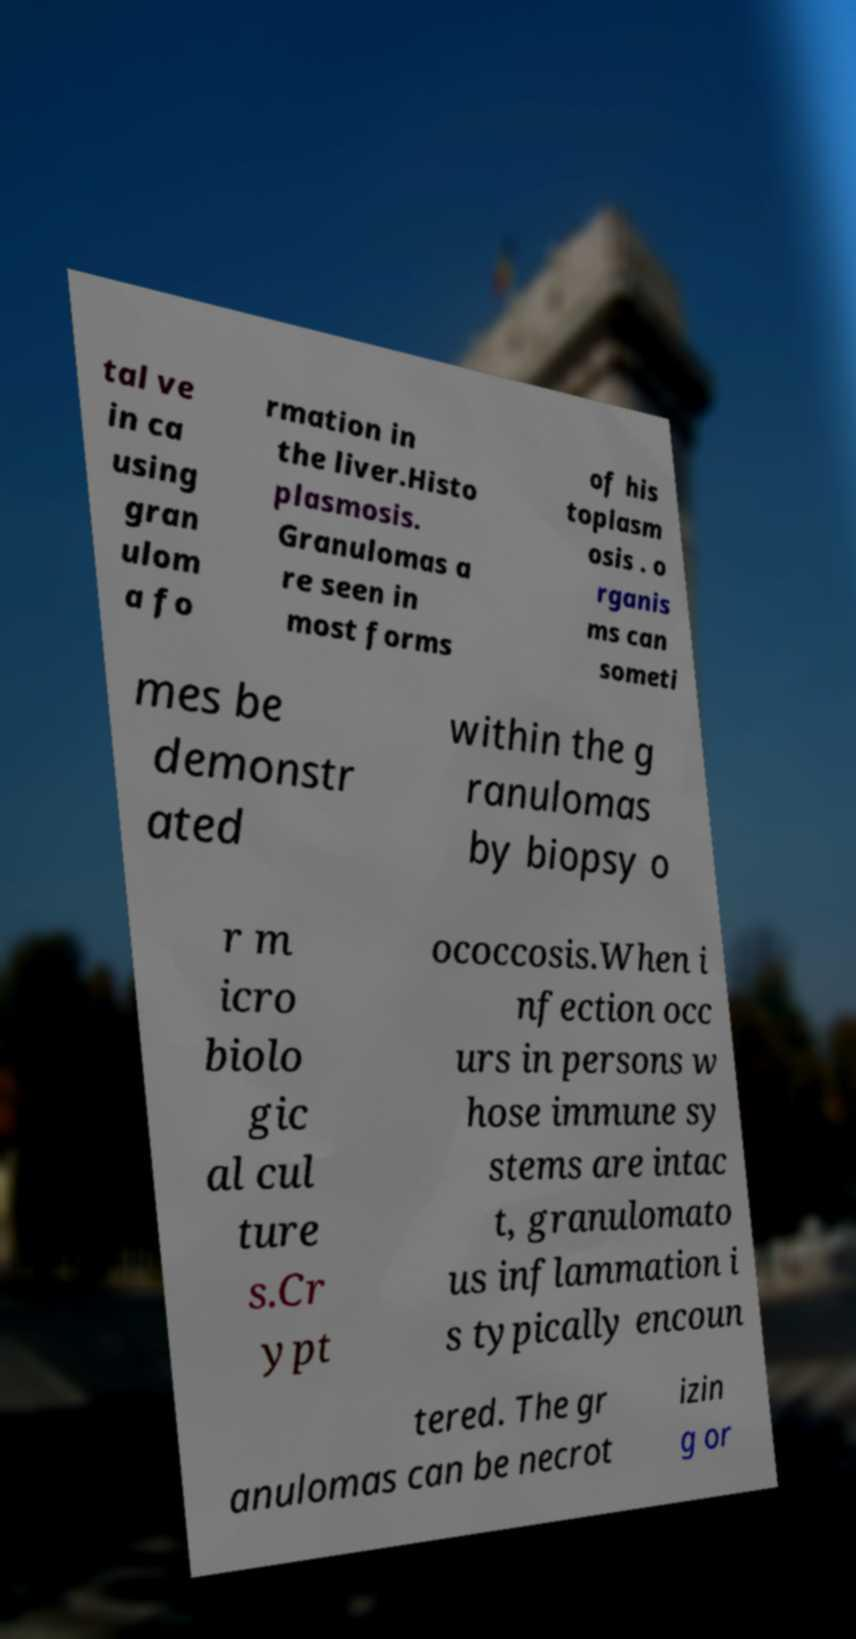Could you extract and type out the text from this image? tal ve in ca using gran ulom a fo rmation in the liver.Histo plasmosis. Granulomas a re seen in most forms of his toplasm osis . o rganis ms can someti mes be demonstr ated within the g ranulomas by biopsy o r m icro biolo gic al cul ture s.Cr ypt ococcosis.When i nfection occ urs in persons w hose immune sy stems are intac t, granulomato us inflammation i s typically encoun tered. The gr anulomas can be necrot izin g or 